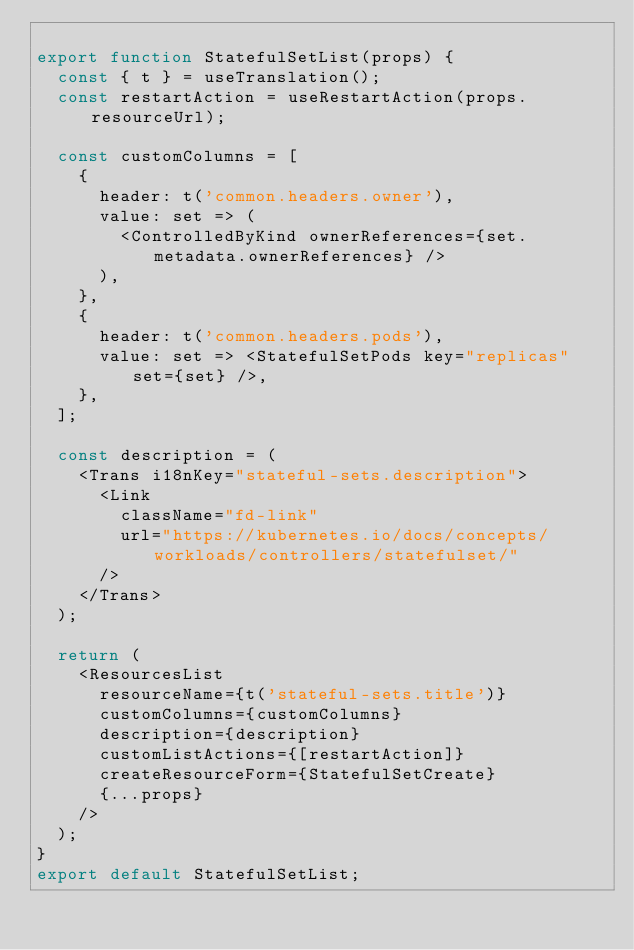Convert code to text. <code><loc_0><loc_0><loc_500><loc_500><_JavaScript_>
export function StatefulSetList(props) {
  const { t } = useTranslation();
  const restartAction = useRestartAction(props.resourceUrl);

  const customColumns = [
    {
      header: t('common.headers.owner'),
      value: set => (
        <ControlledByKind ownerReferences={set.metadata.ownerReferences} />
      ),
    },
    {
      header: t('common.headers.pods'),
      value: set => <StatefulSetPods key="replicas" set={set} />,
    },
  ];

  const description = (
    <Trans i18nKey="stateful-sets.description">
      <Link
        className="fd-link"
        url="https://kubernetes.io/docs/concepts/workloads/controllers/statefulset/"
      />
    </Trans>
  );

  return (
    <ResourcesList
      resourceName={t('stateful-sets.title')}
      customColumns={customColumns}
      description={description}
      customListActions={[restartAction]}
      createResourceForm={StatefulSetCreate}
      {...props}
    />
  );
}
export default StatefulSetList;
</code> 